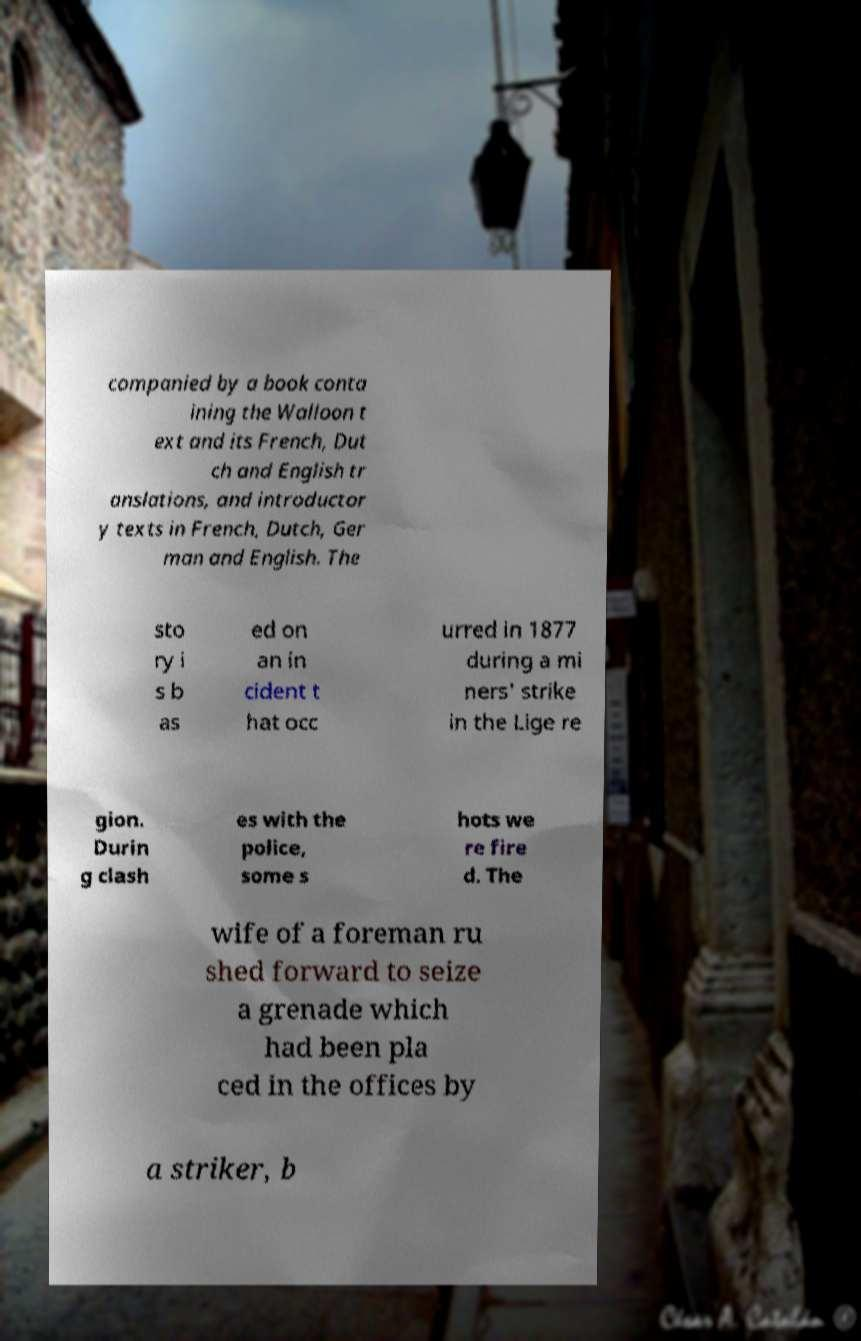Could you extract and type out the text from this image? companied by a book conta ining the Walloon t ext and its French, Dut ch and English tr anslations, and introductor y texts in French, Dutch, Ger man and English. The sto ry i s b as ed on an in cident t hat occ urred in 1877 during a mi ners' strike in the Lige re gion. Durin g clash es with the police, some s hots we re fire d. The wife of a foreman ru shed forward to seize a grenade which had been pla ced in the offices by a striker, b 